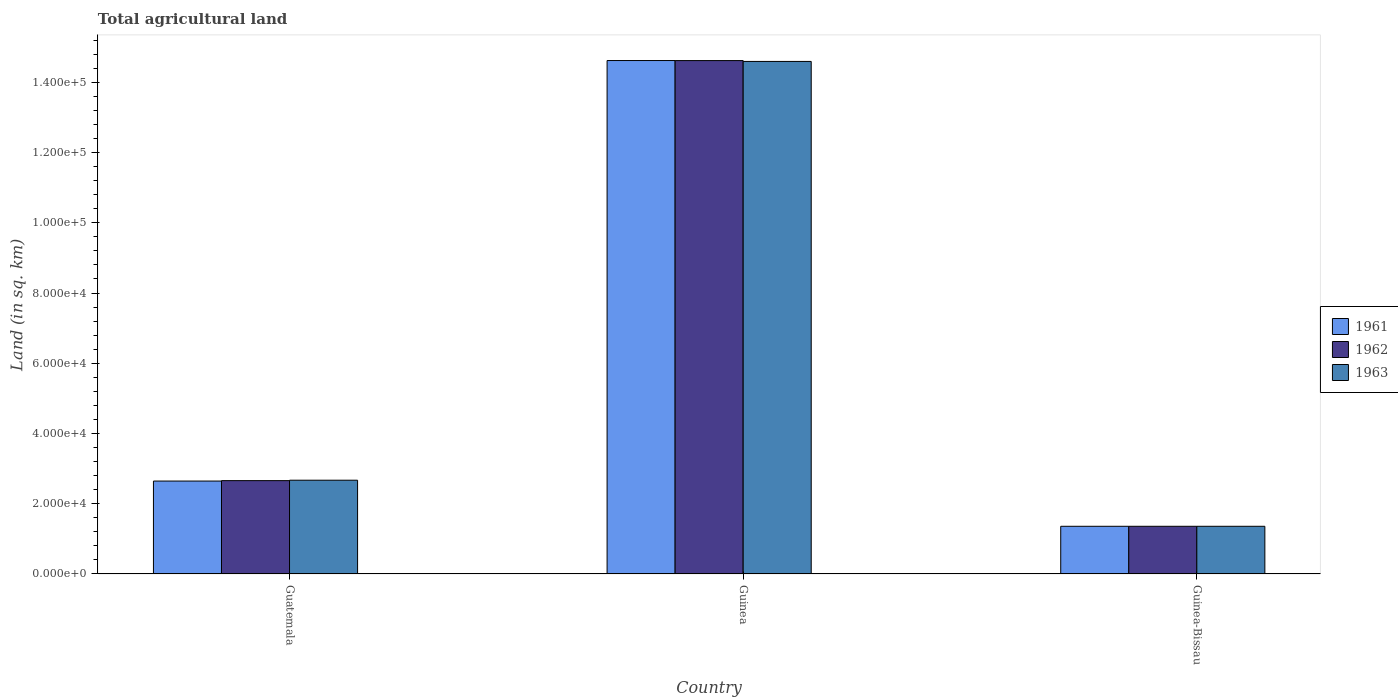How many different coloured bars are there?
Keep it short and to the point. 3. How many bars are there on the 2nd tick from the left?
Ensure brevity in your answer.  3. What is the label of the 1st group of bars from the left?
Offer a terse response. Guatemala. What is the total agricultural land in 1962 in Guinea?
Provide a succinct answer. 1.46e+05. Across all countries, what is the maximum total agricultural land in 1962?
Offer a very short reply. 1.46e+05. Across all countries, what is the minimum total agricultural land in 1962?
Your response must be concise. 1.36e+04. In which country was the total agricultural land in 1963 maximum?
Offer a very short reply. Guinea. In which country was the total agricultural land in 1961 minimum?
Offer a very short reply. Guinea-Bissau. What is the total total agricultural land in 1963 in the graph?
Your answer should be very brief. 1.86e+05. What is the difference between the total agricultural land in 1962 in Guinea and that in Guinea-Bissau?
Your answer should be compact. 1.33e+05. What is the difference between the total agricultural land in 1961 in Guatemala and the total agricultural land in 1963 in Guinea?
Provide a succinct answer. -1.19e+05. What is the average total agricultural land in 1962 per country?
Offer a very short reply. 6.21e+04. What is the difference between the total agricultural land of/in 1962 and total agricultural land of/in 1961 in Guinea?
Offer a terse response. -10. What is the ratio of the total agricultural land in 1961 in Guatemala to that in Guinea?
Ensure brevity in your answer.  0.18. Is the total agricultural land in 1962 in Guatemala less than that in Guinea-Bissau?
Your answer should be very brief. No. What is the difference between the highest and the second highest total agricultural land in 1962?
Give a very brief answer. 1.30e+04. What is the difference between the highest and the lowest total agricultural land in 1963?
Ensure brevity in your answer.  1.32e+05. What does the 2nd bar from the left in Guinea-Bissau represents?
Your answer should be compact. 1962. Is it the case that in every country, the sum of the total agricultural land in 1961 and total agricultural land in 1962 is greater than the total agricultural land in 1963?
Keep it short and to the point. Yes. How many bars are there?
Your response must be concise. 9. What is the difference between two consecutive major ticks on the Y-axis?
Keep it short and to the point. 2.00e+04. Does the graph contain any zero values?
Ensure brevity in your answer.  No. Does the graph contain grids?
Ensure brevity in your answer.  No. Where does the legend appear in the graph?
Give a very brief answer. Center right. What is the title of the graph?
Your response must be concise. Total agricultural land. Does "2005" appear as one of the legend labels in the graph?
Your answer should be compact. No. What is the label or title of the Y-axis?
Your answer should be very brief. Land (in sq. km). What is the Land (in sq. km) in 1961 in Guatemala?
Give a very brief answer. 2.65e+04. What is the Land (in sq. km) in 1962 in Guatemala?
Your answer should be compact. 2.66e+04. What is the Land (in sq. km) of 1963 in Guatemala?
Keep it short and to the point. 2.67e+04. What is the Land (in sq. km) of 1961 in Guinea?
Keep it short and to the point. 1.46e+05. What is the Land (in sq. km) in 1962 in Guinea?
Offer a very short reply. 1.46e+05. What is the Land (in sq. km) in 1963 in Guinea?
Offer a very short reply. 1.46e+05. What is the Land (in sq. km) in 1961 in Guinea-Bissau?
Give a very brief answer. 1.36e+04. What is the Land (in sq. km) of 1962 in Guinea-Bissau?
Offer a very short reply. 1.36e+04. What is the Land (in sq. km) of 1963 in Guinea-Bissau?
Your answer should be very brief. 1.36e+04. Across all countries, what is the maximum Land (in sq. km) in 1961?
Give a very brief answer. 1.46e+05. Across all countries, what is the maximum Land (in sq. km) of 1962?
Give a very brief answer. 1.46e+05. Across all countries, what is the maximum Land (in sq. km) in 1963?
Your response must be concise. 1.46e+05. Across all countries, what is the minimum Land (in sq. km) of 1961?
Your response must be concise. 1.36e+04. Across all countries, what is the minimum Land (in sq. km) of 1962?
Offer a very short reply. 1.36e+04. Across all countries, what is the minimum Land (in sq. km) of 1963?
Provide a succinct answer. 1.36e+04. What is the total Land (in sq. km) of 1961 in the graph?
Your answer should be very brief. 1.86e+05. What is the total Land (in sq. km) in 1962 in the graph?
Your answer should be very brief. 1.86e+05. What is the total Land (in sq. km) in 1963 in the graph?
Ensure brevity in your answer.  1.86e+05. What is the difference between the Land (in sq. km) of 1961 in Guatemala and that in Guinea?
Offer a terse response. -1.20e+05. What is the difference between the Land (in sq. km) in 1962 in Guatemala and that in Guinea?
Offer a terse response. -1.20e+05. What is the difference between the Land (in sq. km) in 1963 in Guatemala and that in Guinea?
Your answer should be very brief. -1.19e+05. What is the difference between the Land (in sq. km) in 1961 in Guatemala and that in Guinea-Bissau?
Offer a terse response. 1.29e+04. What is the difference between the Land (in sq. km) of 1962 in Guatemala and that in Guinea-Bissau?
Offer a very short reply. 1.30e+04. What is the difference between the Land (in sq. km) in 1963 in Guatemala and that in Guinea-Bissau?
Ensure brevity in your answer.  1.31e+04. What is the difference between the Land (in sq. km) of 1961 in Guinea and that in Guinea-Bissau?
Your answer should be compact. 1.33e+05. What is the difference between the Land (in sq. km) in 1962 in Guinea and that in Guinea-Bissau?
Offer a terse response. 1.33e+05. What is the difference between the Land (in sq. km) in 1963 in Guinea and that in Guinea-Bissau?
Offer a terse response. 1.32e+05. What is the difference between the Land (in sq. km) of 1961 in Guatemala and the Land (in sq. km) of 1962 in Guinea?
Your response must be concise. -1.20e+05. What is the difference between the Land (in sq. km) of 1961 in Guatemala and the Land (in sq. km) of 1963 in Guinea?
Offer a terse response. -1.19e+05. What is the difference between the Land (in sq. km) in 1962 in Guatemala and the Land (in sq. km) in 1963 in Guinea?
Your answer should be very brief. -1.19e+05. What is the difference between the Land (in sq. km) of 1961 in Guatemala and the Land (in sq. km) of 1962 in Guinea-Bissau?
Your response must be concise. 1.29e+04. What is the difference between the Land (in sq. km) of 1961 in Guatemala and the Land (in sq. km) of 1963 in Guinea-Bissau?
Give a very brief answer. 1.29e+04. What is the difference between the Land (in sq. km) in 1962 in Guatemala and the Land (in sq. km) in 1963 in Guinea-Bissau?
Your answer should be compact. 1.30e+04. What is the difference between the Land (in sq. km) in 1961 in Guinea and the Land (in sq. km) in 1962 in Guinea-Bissau?
Offer a very short reply. 1.33e+05. What is the difference between the Land (in sq. km) in 1961 in Guinea and the Land (in sq. km) in 1963 in Guinea-Bissau?
Offer a very short reply. 1.33e+05. What is the difference between the Land (in sq. km) of 1962 in Guinea and the Land (in sq. km) of 1963 in Guinea-Bissau?
Ensure brevity in your answer.  1.33e+05. What is the average Land (in sq. km) in 1961 per country?
Offer a very short reply. 6.21e+04. What is the average Land (in sq. km) in 1962 per country?
Keep it short and to the point. 6.21e+04. What is the average Land (in sq. km) in 1963 per country?
Your response must be concise. 6.21e+04. What is the difference between the Land (in sq. km) of 1961 and Land (in sq. km) of 1962 in Guatemala?
Keep it short and to the point. -120. What is the difference between the Land (in sq. km) of 1961 and Land (in sq. km) of 1963 in Guatemala?
Your answer should be very brief. -240. What is the difference between the Land (in sq. km) in 1962 and Land (in sq. km) in 1963 in Guatemala?
Your answer should be compact. -120. What is the difference between the Land (in sq. km) in 1961 and Land (in sq. km) in 1963 in Guinea?
Offer a terse response. 250. What is the difference between the Land (in sq. km) of 1962 and Land (in sq. km) of 1963 in Guinea?
Offer a very short reply. 240. What is the difference between the Land (in sq. km) of 1962 and Land (in sq. km) of 1963 in Guinea-Bissau?
Make the answer very short. 0. What is the ratio of the Land (in sq. km) in 1961 in Guatemala to that in Guinea?
Your answer should be very brief. 0.18. What is the ratio of the Land (in sq. km) in 1962 in Guatemala to that in Guinea?
Your response must be concise. 0.18. What is the ratio of the Land (in sq. km) in 1963 in Guatemala to that in Guinea?
Make the answer very short. 0.18. What is the ratio of the Land (in sq. km) of 1961 in Guatemala to that in Guinea-Bissau?
Provide a short and direct response. 1.95. What is the ratio of the Land (in sq. km) in 1962 in Guatemala to that in Guinea-Bissau?
Your answer should be compact. 1.96. What is the ratio of the Land (in sq. km) of 1963 in Guatemala to that in Guinea-Bissau?
Provide a short and direct response. 1.97. What is the ratio of the Land (in sq. km) in 1961 in Guinea to that in Guinea-Bissau?
Make the answer very short. 10.77. What is the ratio of the Land (in sq. km) in 1962 in Guinea to that in Guinea-Bissau?
Provide a succinct answer. 10.77. What is the ratio of the Land (in sq. km) in 1963 in Guinea to that in Guinea-Bissau?
Offer a very short reply. 10.75. What is the difference between the highest and the second highest Land (in sq. km) of 1961?
Ensure brevity in your answer.  1.20e+05. What is the difference between the highest and the second highest Land (in sq. km) in 1962?
Offer a very short reply. 1.20e+05. What is the difference between the highest and the second highest Land (in sq. km) of 1963?
Offer a very short reply. 1.19e+05. What is the difference between the highest and the lowest Land (in sq. km) in 1961?
Provide a succinct answer. 1.33e+05. What is the difference between the highest and the lowest Land (in sq. km) of 1962?
Offer a very short reply. 1.33e+05. What is the difference between the highest and the lowest Land (in sq. km) of 1963?
Keep it short and to the point. 1.32e+05. 